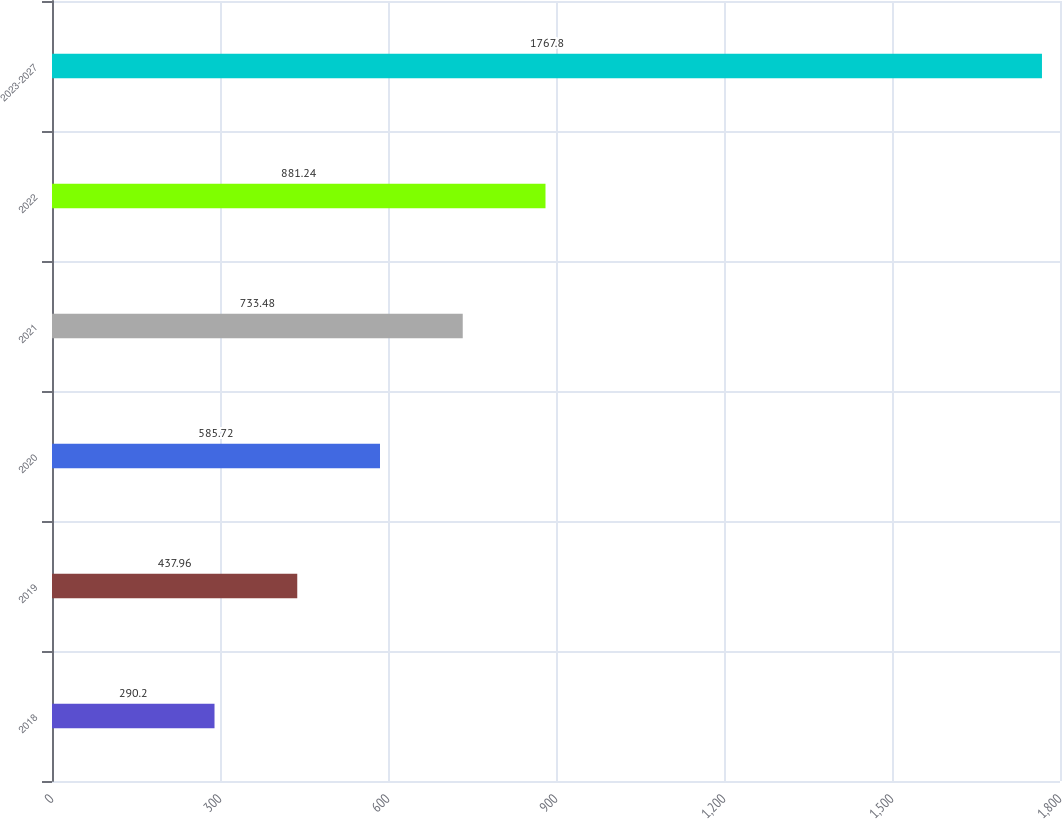<chart> <loc_0><loc_0><loc_500><loc_500><bar_chart><fcel>2018<fcel>2019<fcel>2020<fcel>2021<fcel>2022<fcel>2023-2027<nl><fcel>290.2<fcel>437.96<fcel>585.72<fcel>733.48<fcel>881.24<fcel>1767.8<nl></chart> 